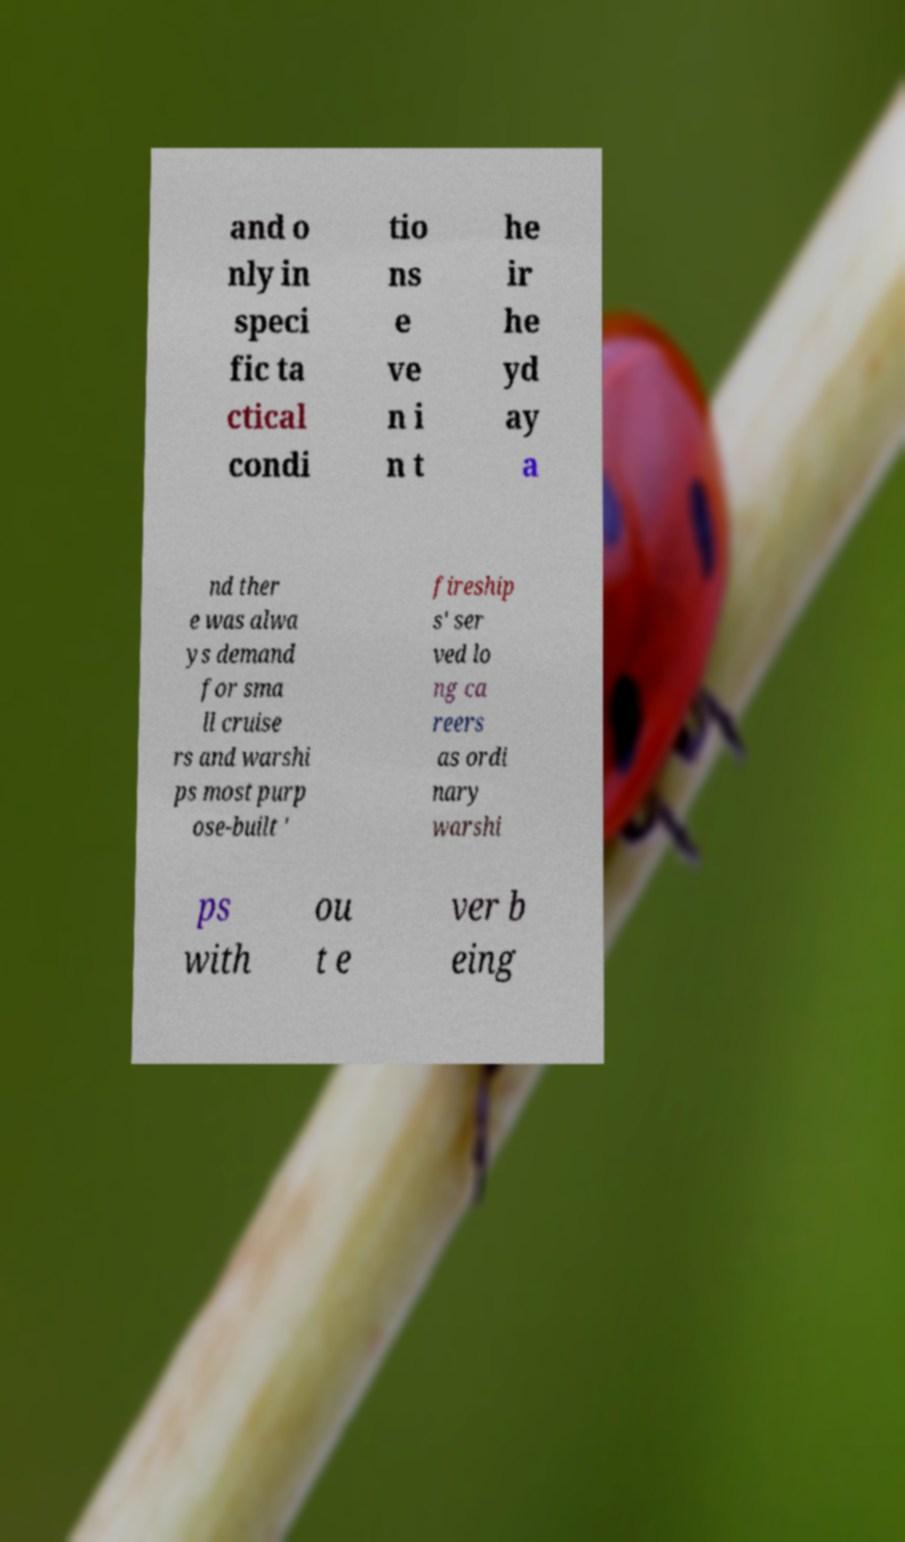Please read and relay the text visible in this image. What does it say? and o nly in speci fic ta ctical condi tio ns e ve n i n t he ir he yd ay a nd ther e was alwa ys demand for sma ll cruise rs and warshi ps most purp ose-built ' fireship s' ser ved lo ng ca reers as ordi nary warshi ps with ou t e ver b eing 